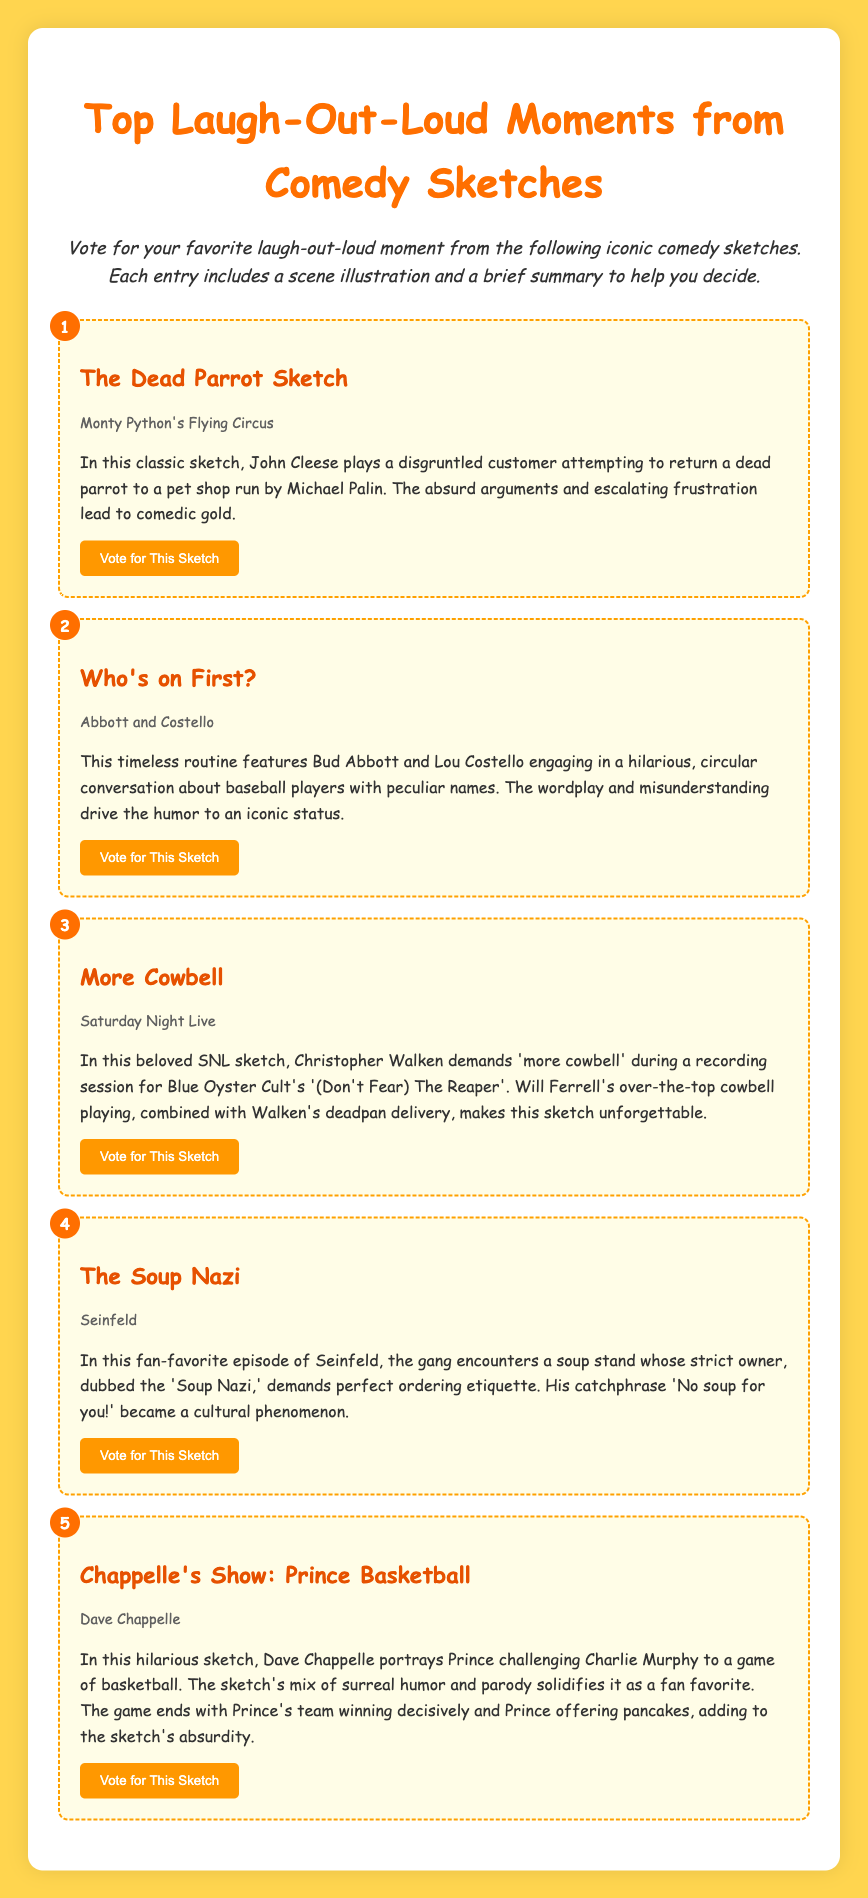What is the title of the first sketch? The title is found in the first sketch item in the document.
Answer: The Dead Parrot Sketch Which comedy show features the sketch titled "More Cowbell"? The show associated with this sketch is mentioned along with its title in the sketch item.
Answer: Saturday Night Live How many sketches are listed in the document? The total number of sketches can be determined by counting the sketch items in the document.
Answer: 5 Who portrayed Prince in the sketch about basketball? The name of the person playing Prince is provided in the summary of the corresponding sketch.
Answer: Dave Chappelle What is the catchphrase of the Soup Nazi? The catchphrase is highlighted in the summary of the related sketch.
Answer: No soup for you! 